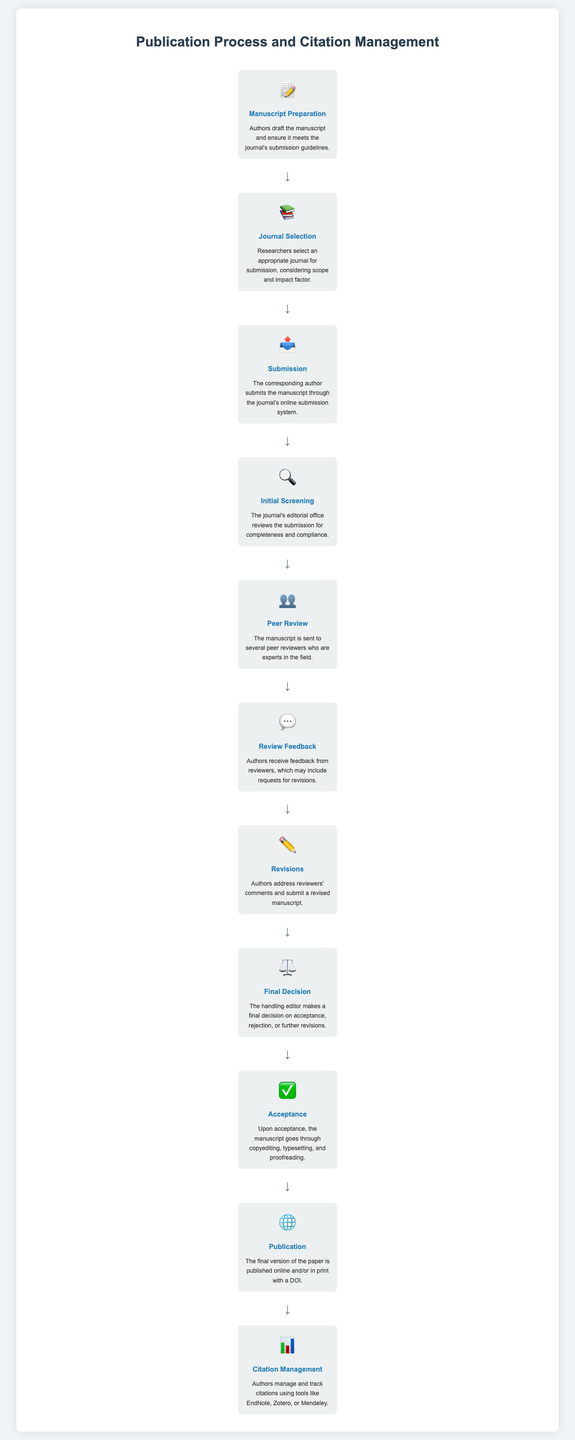What is the first step in the publication process? The first step in the publication process, according to the infographic, is "Manuscript Preparation."
Answer: Manuscript Preparation Which icon represents the "Peer Review" step? The infographic uses the icon of two people (👥) to represent the "Peer Review" step.
Answer: 👥 What happens after the "Review Feedback"? After the "Review Feedback," authors work on "Revisions."
Answer: Revisions How many steps are there from manuscript submission to final publication? The infographic outlines a total of ten steps from manuscript submission to final publication.
Answer: Ten What is the final step in the publication process? The infographic lists "Citation Management" as the final step in the publication process.
Answer: Citation Management What is the icon for "Acceptance"? The "Acceptance" step is represented by the checkmark icon (✅) in the infographic.
Answer: ✅ Which step includes "typesetting and proofreading"? The step that includes "typesetting and proofreading" is "Acceptance."
Answer: Acceptance What do authors use for citation management? Authors manage citations using tools like EndNote, Zotero, or Mendeley, as stated in the infographic.
Answer: EndNote, Zotero, or Mendeley What title does the infographic have? The title of the infographic is "Publication Process and Citation Management."
Answer: Publication Process and Citation Management 